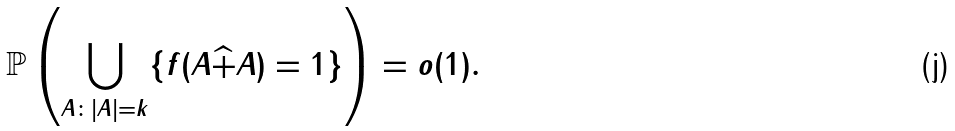<formula> <loc_0><loc_0><loc_500><loc_500>\mathbb { P } \left ( \bigcup _ { A \colon | A | = k } \{ f ( A \widehat { + } A ) = 1 \} \right ) = o ( 1 ) .</formula> 